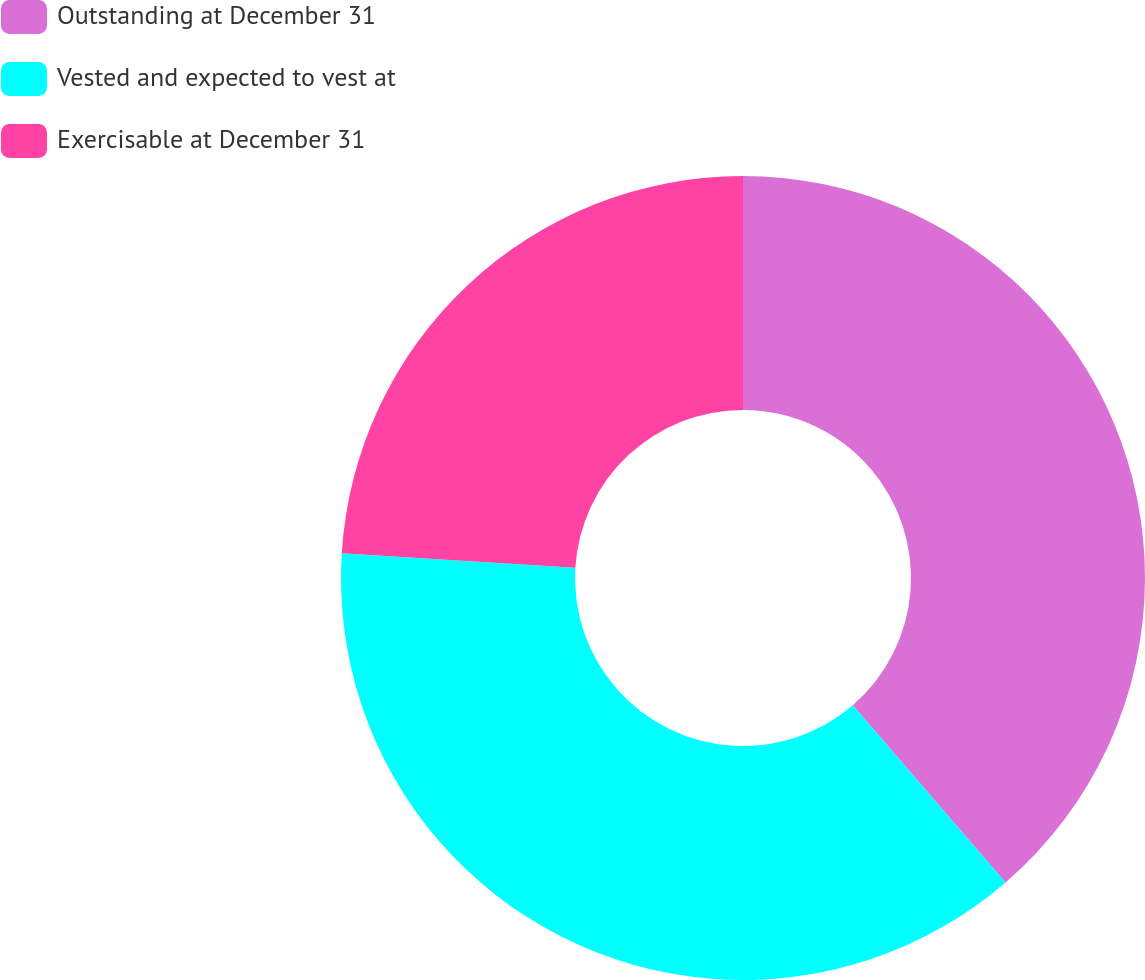Convert chart to OTSL. <chart><loc_0><loc_0><loc_500><loc_500><pie_chart><fcel>Outstanding at December 31<fcel>Vested and expected to vest at<fcel>Exercisable at December 31<nl><fcel>38.67%<fcel>37.3%<fcel>24.02%<nl></chart> 